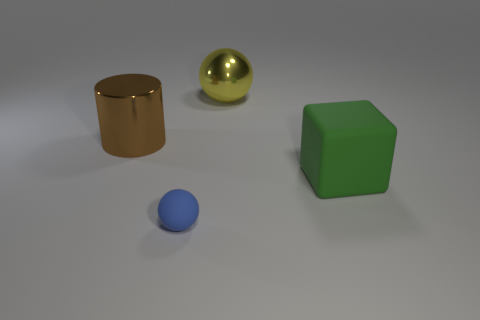Add 1 big yellow blocks. How many objects exist? 5 Subtract all cylinders. How many objects are left? 3 Add 1 red metal cubes. How many red metal cubes exist? 1 Subtract 1 green blocks. How many objects are left? 3 Subtract all small metallic things. Subtract all big green matte things. How many objects are left? 3 Add 3 yellow metallic spheres. How many yellow metallic spheres are left? 4 